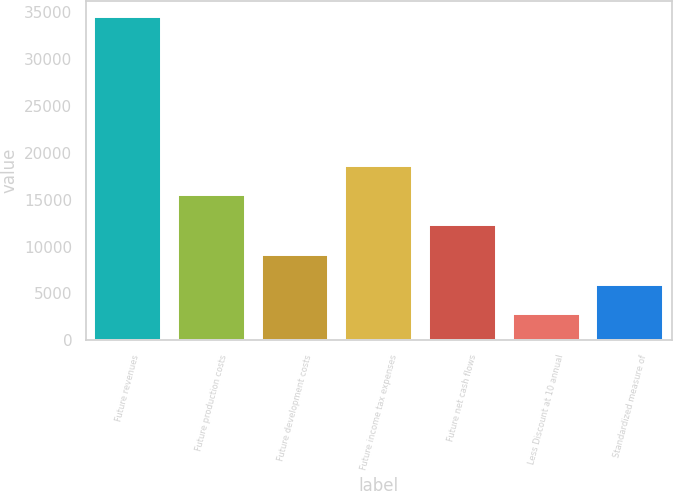<chart> <loc_0><loc_0><loc_500><loc_500><bar_chart><fcel>Future revenues<fcel>Future production costs<fcel>Future development costs<fcel>Future income tax expenses<fcel>Future net cash flows<fcel>Less Discount at 10 annual<fcel>Standardized measure of<nl><fcel>34495<fcel>15451<fcel>9103<fcel>18625<fcel>12277<fcel>2755<fcel>5929<nl></chart> 